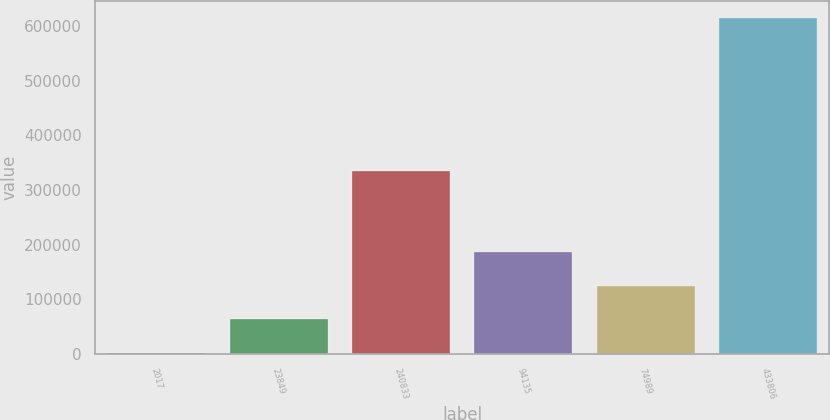Convert chart. <chart><loc_0><loc_0><loc_500><loc_500><bar_chart><fcel>2017<fcel>23849<fcel>240833<fcel>94135<fcel>74989<fcel>433806<nl><fcel>2016<fcel>63337.7<fcel>335498<fcel>185981<fcel>124659<fcel>615233<nl></chart> 